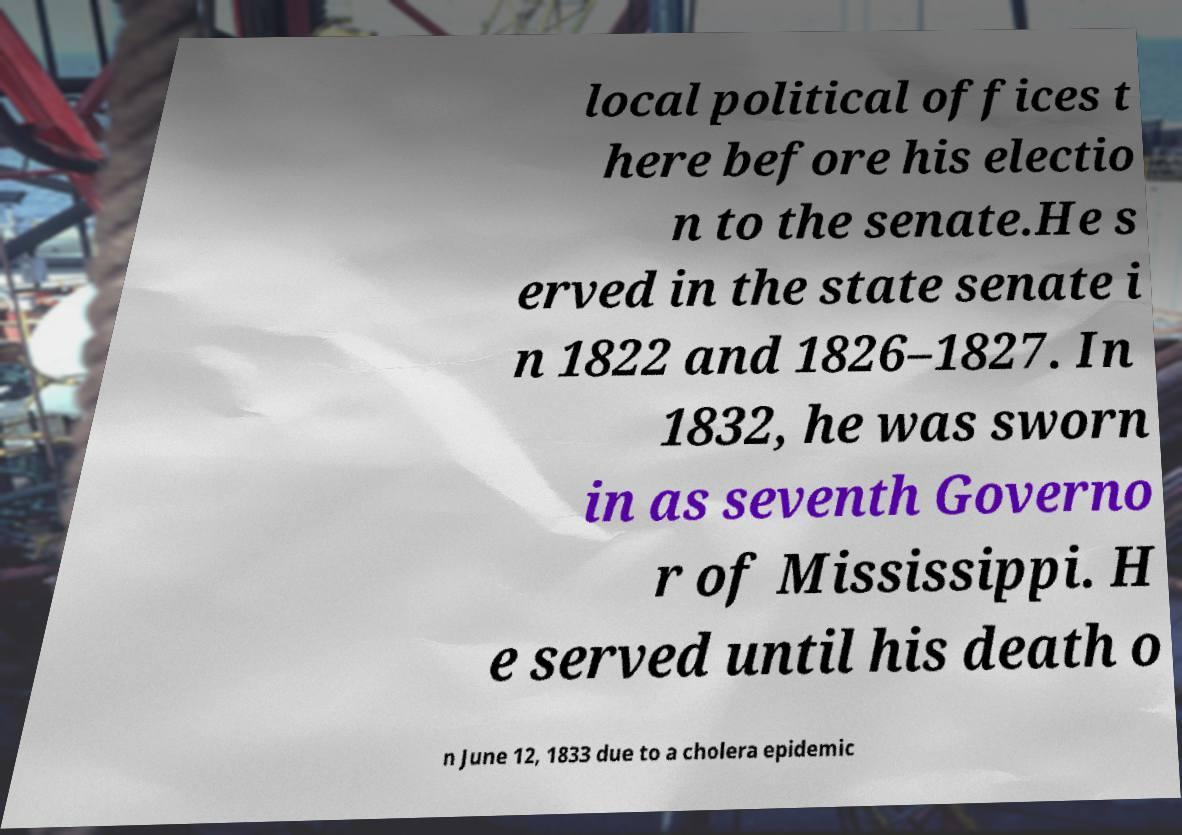Please identify and transcribe the text found in this image. local political offices t here before his electio n to the senate.He s erved in the state senate i n 1822 and 1826–1827. In 1832, he was sworn in as seventh Governo r of Mississippi. H e served until his death o n June 12, 1833 due to a cholera epidemic 